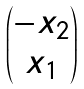Convert formula to latex. <formula><loc_0><loc_0><loc_500><loc_500>\begin{pmatrix} - x _ { 2 } \\ x _ { 1 } \end{pmatrix}</formula> 